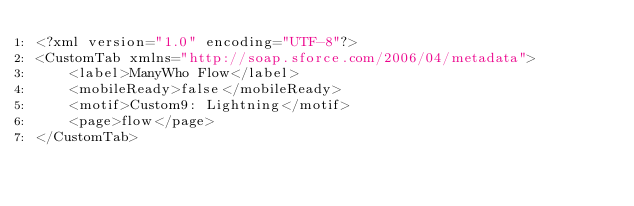Convert code to text. <code><loc_0><loc_0><loc_500><loc_500><_SQL_><?xml version="1.0" encoding="UTF-8"?>
<CustomTab xmlns="http://soap.sforce.com/2006/04/metadata">
    <label>ManyWho Flow</label>
    <mobileReady>false</mobileReady>
    <motif>Custom9: Lightning</motif>
    <page>flow</page>
</CustomTab>
</code> 